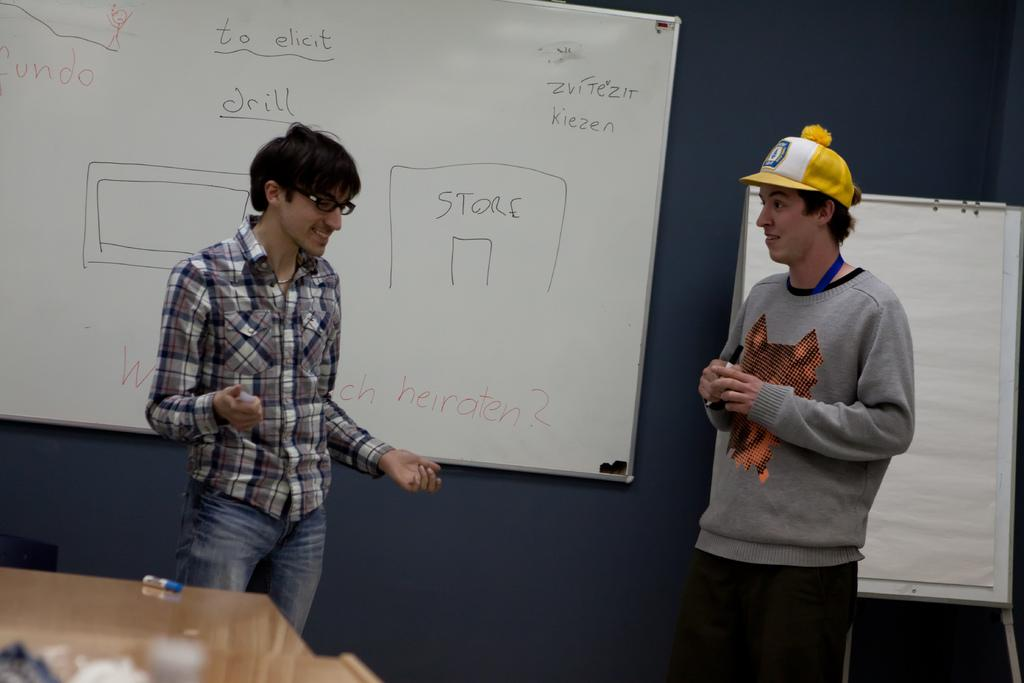<image>
Describe the image concisely. Two young men are talking in front of a white board with phrases "to elect" and "drill" written on it. 